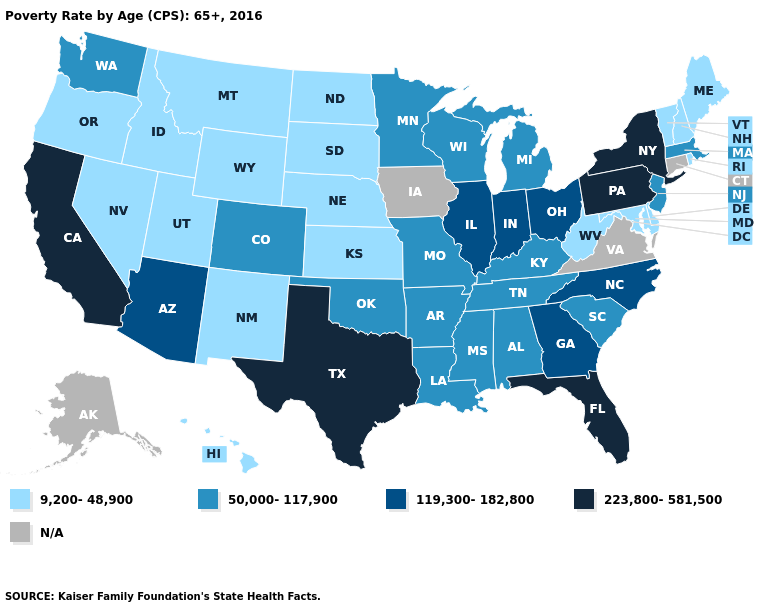Name the states that have a value in the range 50,000-117,900?
Be succinct. Alabama, Arkansas, Colorado, Kentucky, Louisiana, Massachusetts, Michigan, Minnesota, Mississippi, Missouri, New Jersey, Oklahoma, South Carolina, Tennessee, Washington, Wisconsin. Does North Dakota have the lowest value in the USA?
Concise answer only. Yes. Name the states that have a value in the range 223,800-581,500?
Write a very short answer. California, Florida, New York, Pennsylvania, Texas. Does Wisconsin have the lowest value in the USA?
Be succinct. No. What is the lowest value in the USA?
Keep it brief. 9,200-48,900. What is the highest value in the USA?
Quick response, please. 223,800-581,500. Among the states that border North Dakota , which have the highest value?
Short answer required. Minnesota. Does Maryland have the lowest value in the South?
Answer briefly. Yes. What is the lowest value in the USA?
Keep it brief. 9,200-48,900. Name the states that have a value in the range 50,000-117,900?
Quick response, please. Alabama, Arkansas, Colorado, Kentucky, Louisiana, Massachusetts, Michigan, Minnesota, Mississippi, Missouri, New Jersey, Oklahoma, South Carolina, Tennessee, Washington, Wisconsin. Is the legend a continuous bar?
Be succinct. No. What is the highest value in states that border New Hampshire?
Quick response, please. 50,000-117,900. What is the value of New Mexico?
Keep it brief. 9,200-48,900. 